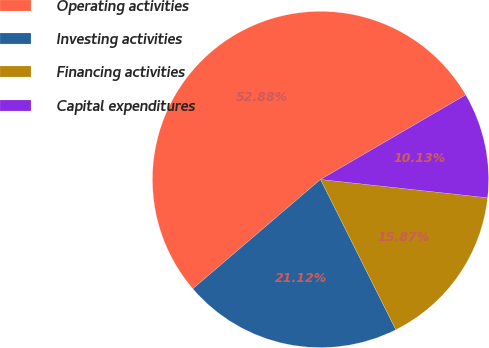Convert chart to OTSL. <chart><loc_0><loc_0><loc_500><loc_500><pie_chart><fcel>Operating activities<fcel>Investing activities<fcel>Financing activities<fcel>Capital expenditures<nl><fcel>52.87%<fcel>21.12%<fcel>15.87%<fcel>10.13%<nl></chart> 